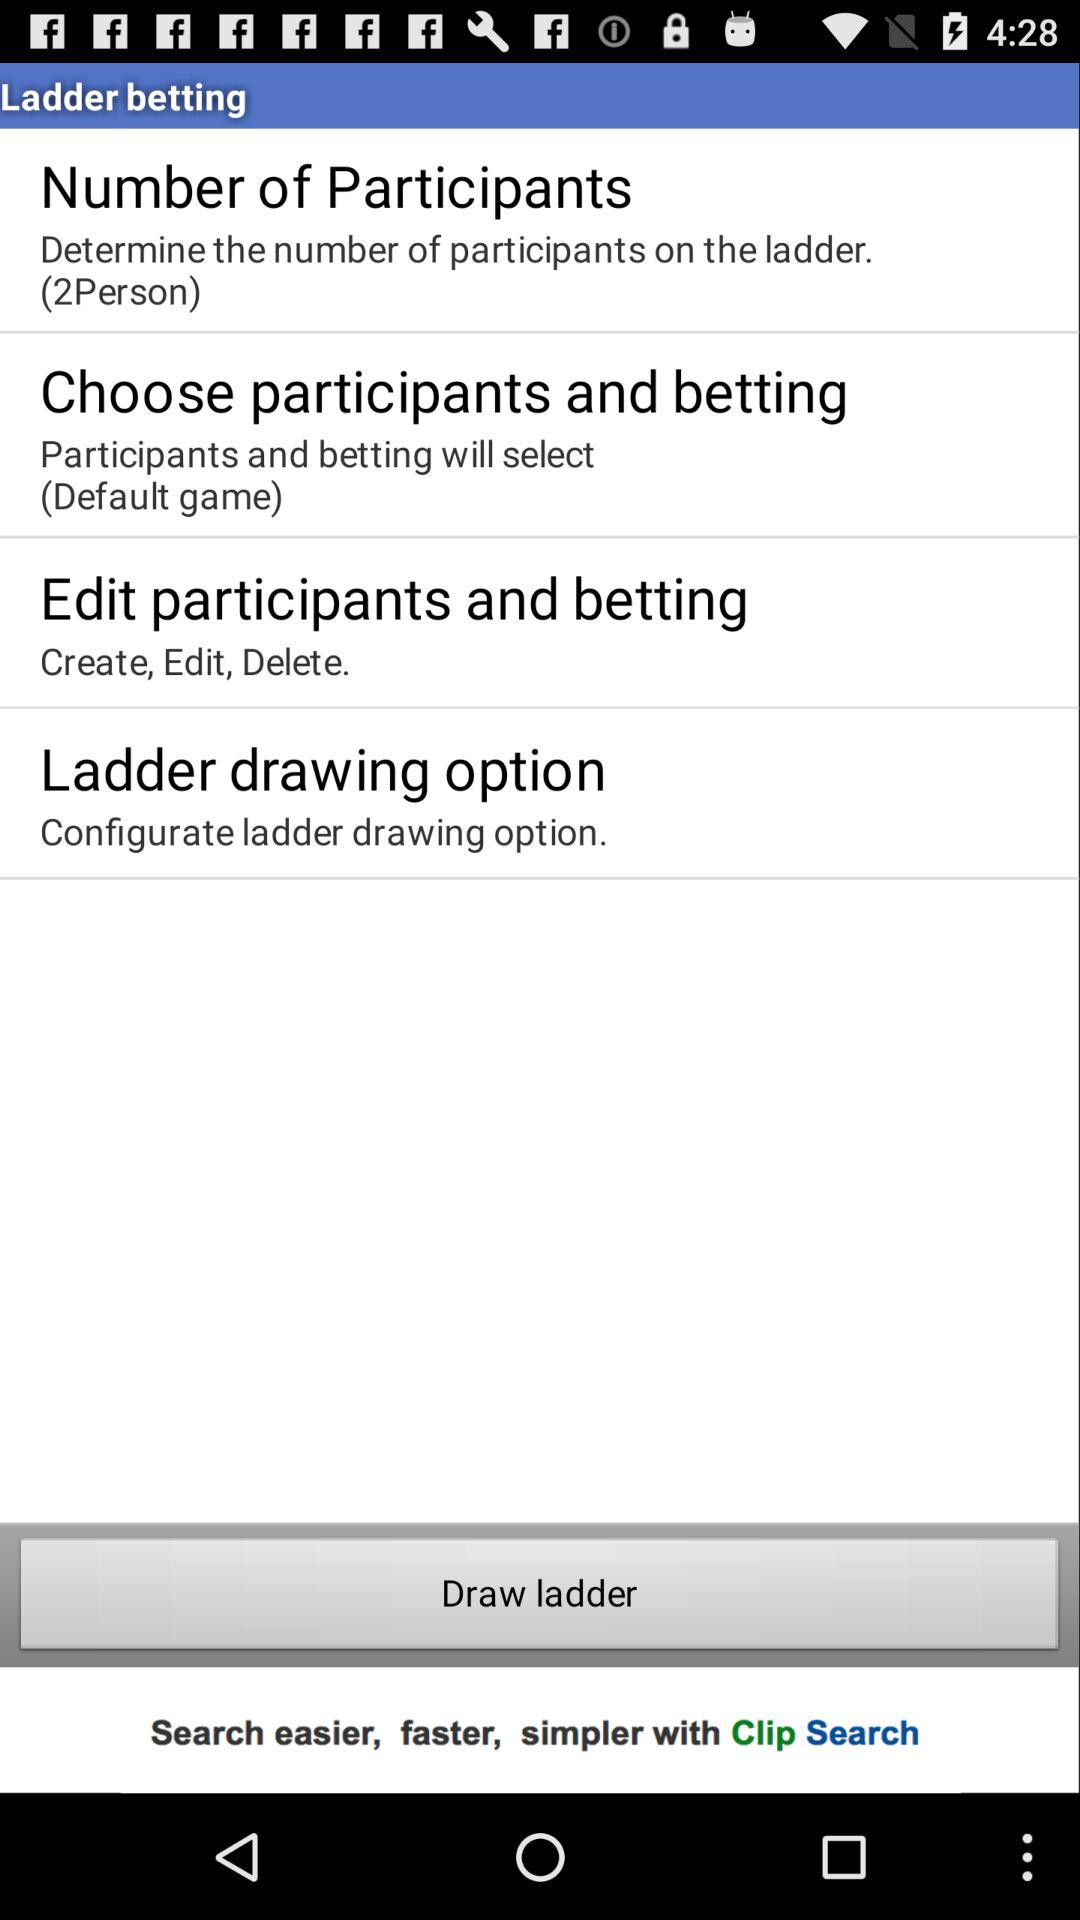How many participants are there by default?
Answer the question using a single word or phrase. 2 